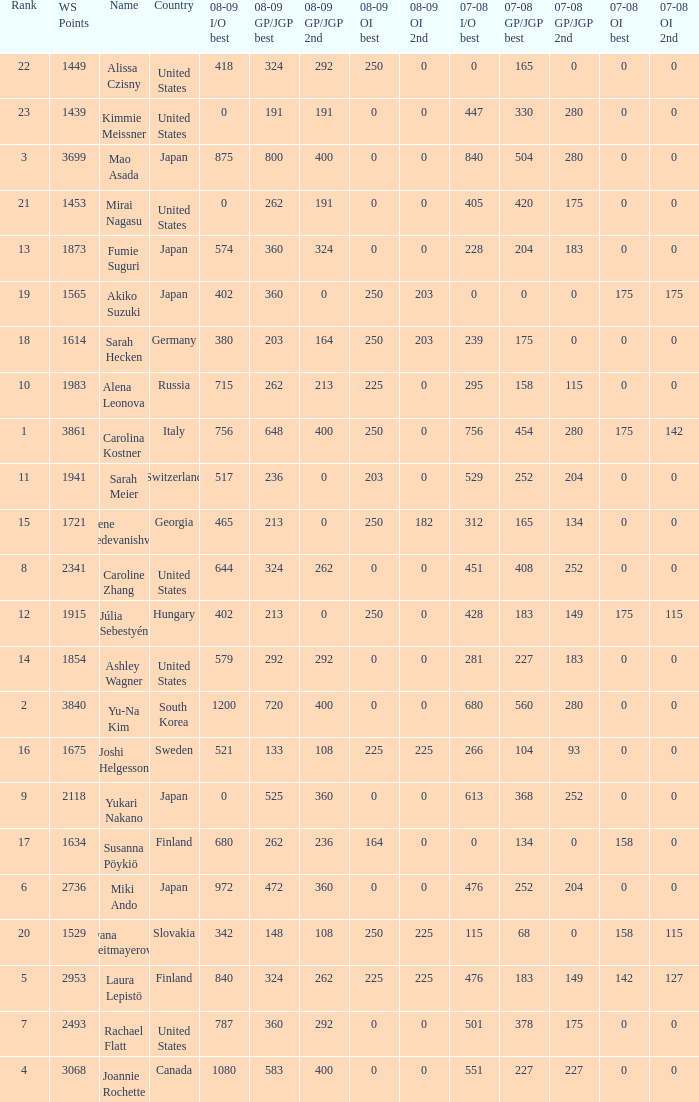What is the total 07-08 gp/jgp 2nd with the name mao asada 280.0. Parse the table in full. {'header': ['Rank', 'WS Points', 'Name', 'Country', '08-09 I/O best', '08-09 GP/JGP best', '08-09 GP/JGP 2nd', '08-09 OI best', '08-09 OI 2nd', '07-08 I/O best', '07-08 GP/JGP best', '07-08 GP/JGP 2nd', '07-08 OI best', '07-08 OI 2nd'], 'rows': [['22', '1449', 'Alissa Czisny', 'United States', '418', '324', '292', '250', '0', '0', '165', '0', '0', '0'], ['23', '1439', 'Kimmie Meissner', 'United States', '0', '191', '191', '0', '0', '447', '330', '280', '0', '0'], ['3', '3699', 'Mao Asada', 'Japan', '875', '800', '400', '0', '0', '840', '504', '280', '0', '0'], ['21', '1453', 'Mirai Nagasu', 'United States', '0', '262', '191', '0', '0', '405', '420', '175', '0', '0'], ['13', '1873', 'Fumie Suguri', 'Japan', '574', '360', '324', '0', '0', '228', '204', '183', '0', '0'], ['19', '1565', 'Akiko Suzuki', 'Japan', '402', '360', '0', '250', '203', '0', '0', '0', '175', '175'], ['18', '1614', 'Sarah Hecken', 'Germany', '380', '203', '164', '250', '203', '239', '175', '0', '0', '0'], ['10', '1983', 'Alena Leonova', 'Russia', '715', '262', '213', '225', '0', '295', '158', '115', '0', '0'], ['1', '3861', 'Carolina Kostner', 'Italy', '756', '648', '400', '250', '0', '756', '454', '280', '175', '142'], ['11', '1941', 'Sarah Meier', 'Switzerland', '517', '236', '0', '203', '0', '529', '252', '204', '0', '0'], ['15', '1721', 'Elene Gedevanishvili', 'Georgia', '465', '213', '0', '250', '182', '312', '165', '134', '0', '0'], ['8', '2341', 'Caroline Zhang', 'United States', '644', '324', '262', '0', '0', '451', '408', '252', '0', '0'], ['12', '1915', 'Júlia Sebestyén', 'Hungary', '402', '213', '0', '250', '0', '428', '183', '149', '175', '115'], ['14', '1854', 'Ashley Wagner', 'United States', '579', '292', '292', '0', '0', '281', '227', '183', '0', '0'], ['2', '3840', 'Yu-Na Kim', 'South Korea', '1200', '720', '400', '0', '0', '680', '560', '280', '0', '0'], ['16', '1675', 'Joshi Helgesson', 'Sweden', '521', '133', '108', '225', '225', '266', '104', '93', '0', '0'], ['9', '2118', 'Yukari Nakano', 'Japan', '0', '525', '360', '0', '0', '613', '368', '252', '0', '0'], ['17', '1634', 'Susanna Pöykiö', 'Finland', '680', '262', '236', '164', '0', '0', '134', '0', '158', '0'], ['6', '2736', 'Miki Ando', 'Japan', '972', '472', '360', '0', '0', '476', '252', '204', '0', '0'], ['20', '1529', 'Ivana Reitmayerova', 'Slovakia', '342', '148', '108', '250', '225', '115', '68', '0', '158', '115'], ['5', '2953', 'Laura Lepistö', 'Finland', '840', '324', '262', '225', '225', '476', '183', '149', '142', '127'], ['7', '2493', 'Rachael Flatt', 'United States', '787', '360', '292', '0', '0', '501', '378', '175', '0', '0'], ['4', '3068', 'Joannie Rochette', 'Canada', '1080', '583', '400', '0', '0', '551', '227', '227', '0', '0']]} 